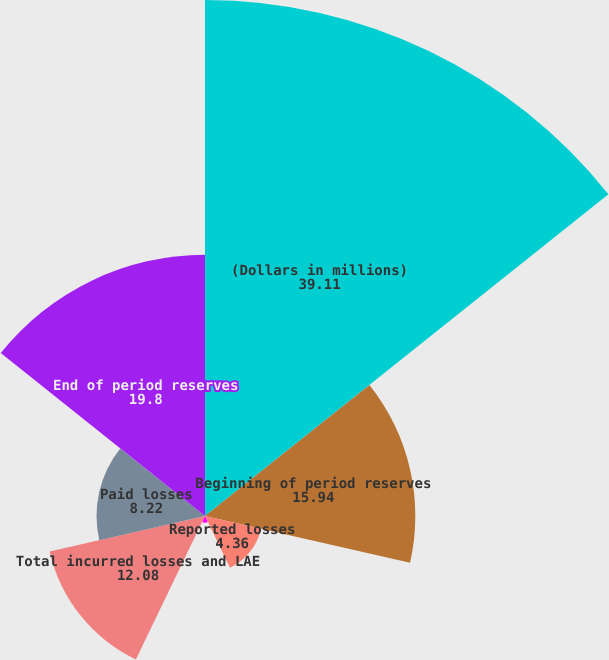<chart> <loc_0><loc_0><loc_500><loc_500><pie_chart><fcel>(Dollars in millions)<fcel>Beginning of period reserves<fcel>Reported losses<fcel>Change in IBNR<fcel>Total incurred losses and LAE<fcel>Paid losses<fcel>End of period reserves<nl><fcel>39.11%<fcel>15.94%<fcel>4.36%<fcel>0.5%<fcel>12.08%<fcel>8.22%<fcel>19.8%<nl></chart> 